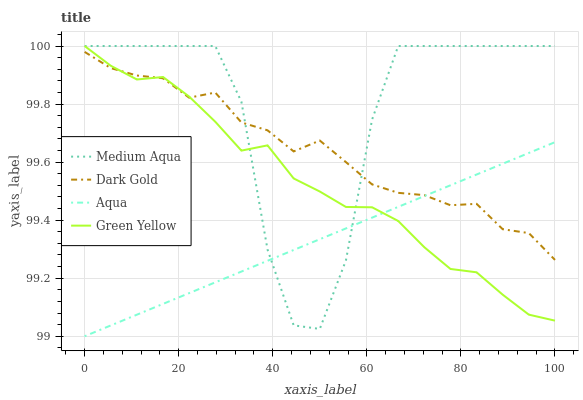Does Aqua have the minimum area under the curve?
Answer yes or no. Yes. Does Medium Aqua have the maximum area under the curve?
Answer yes or no. Yes. Does Green Yellow have the minimum area under the curve?
Answer yes or no. No. Does Green Yellow have the maximum area under the curve?
Answer yes or no. No. Is Aqua the smoothest?
Answer yes or no. Yes. Is Medium Aqua the roughest?
Answer yes or no. Yes. Is Green Yellow the smoothest?
Answer yes or no. No. Is Green Yellow the roughest?
Answer yes or no. No. Does Green Yellow have the lowest value?
Answer yes or no. No. Does Medium Aqua have the highest value?
Answer yes or no. Yes. Does Dark Gold have the highest value?
Answer yes or no. No. Does Dark Gold intersect Medium Aqua?
Answer yes or no. Yes. Is Dark Gold less than Medium Aqua?
Answer yes or no. No. Is Dark Gold greater than Medium Aqua?
Answer yes or no. No. 